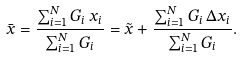Convert formula to latex. <formula><loc_0><loc_0><loc_500><loc_500>\bar { x } = \frac { \sum _ { i = 1 } ^ { N } G _ { i } \, x _ { i } } { \sum _ { i = 1 } ^ { N } G _ { i } } = \tilde { x } + \frac { \sum _ { i = 1 } ^ { N } G _ { i } \, \Delta x _ { i } } { \sum _ { i = 1 } ^ { N } G _ { i } } .</formula> 